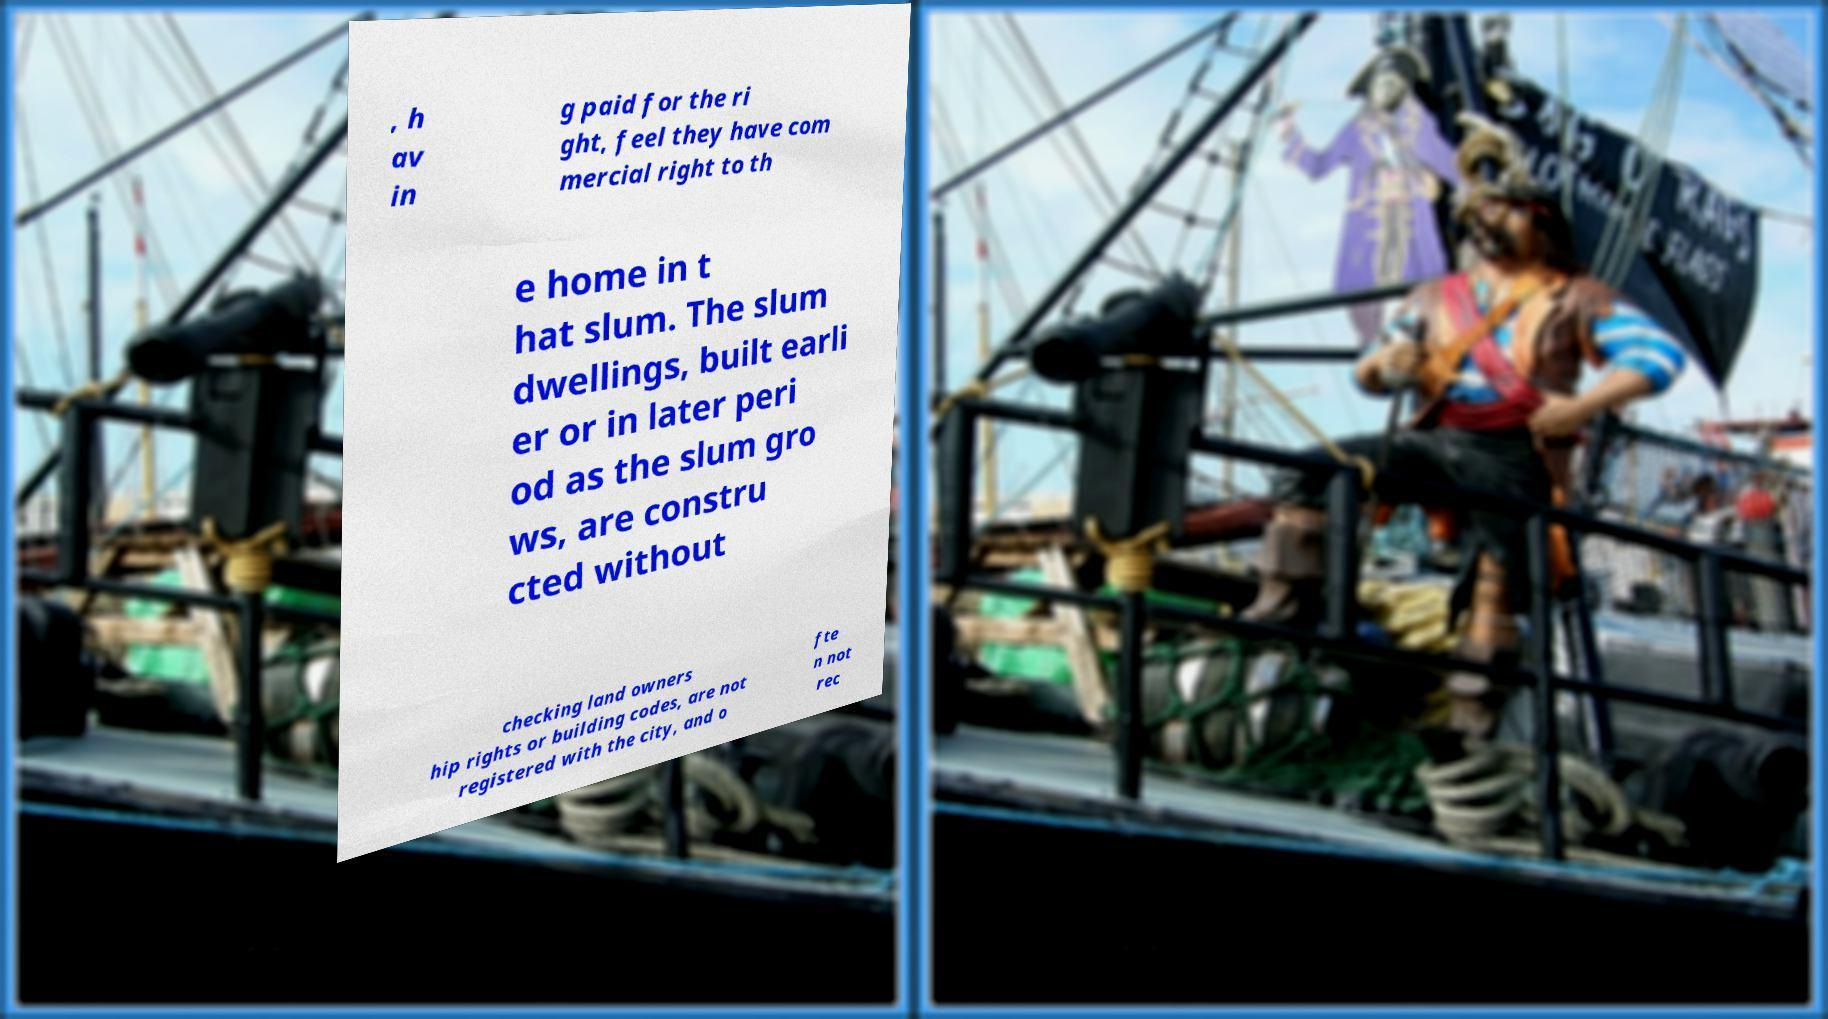What messages or text are displayed in this image? I need them in a readable, typed format. , h av in g paid for the ri ght, feel they have com mercial right to th e home in t hat slum. The slum dwellings, built earli er or in later peri od as the slum gro ws, are constru cted without checking land owners hip rights or building codes, are not registered with the city, and o fte n not rec 